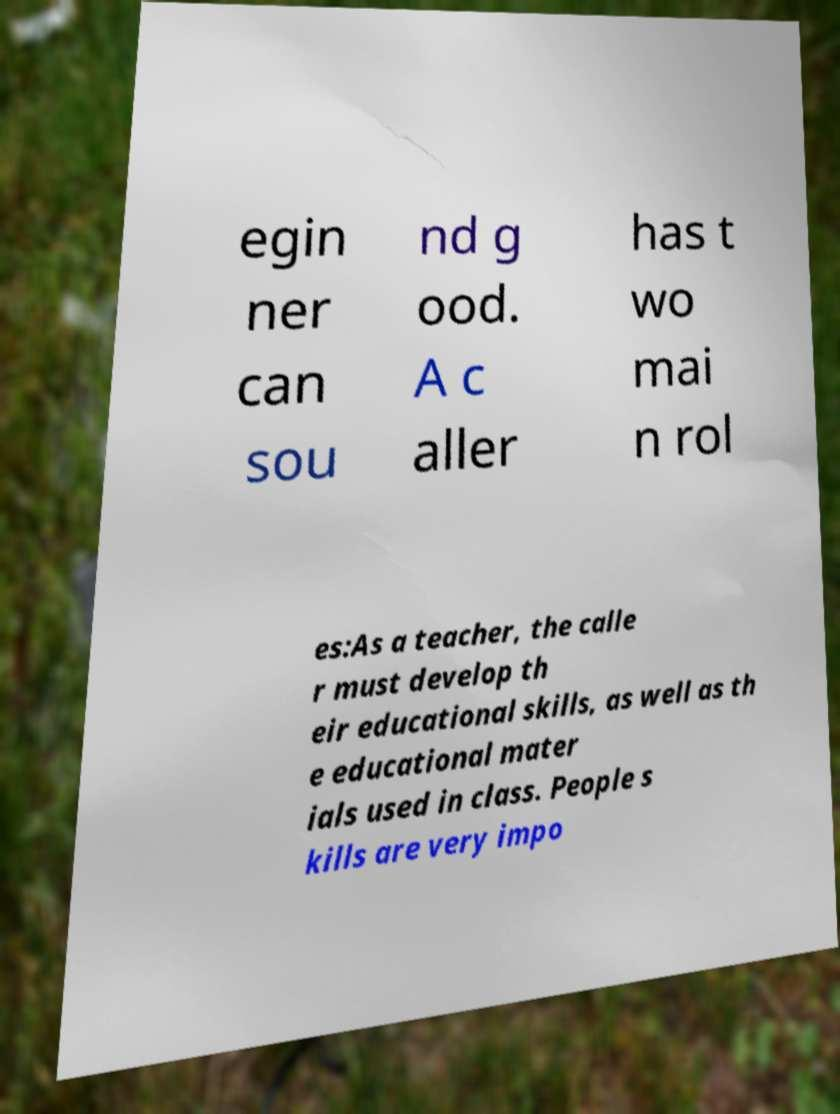What messages or text are displayed in this image? I need them in a readable, typed format. egin ner can sou nd g ood. A c aller has t wo mai n rol es:As a teacher, the calle r must develop th eir educational skills, as well as th e educational mater ials used in class. People s kills are very impo 